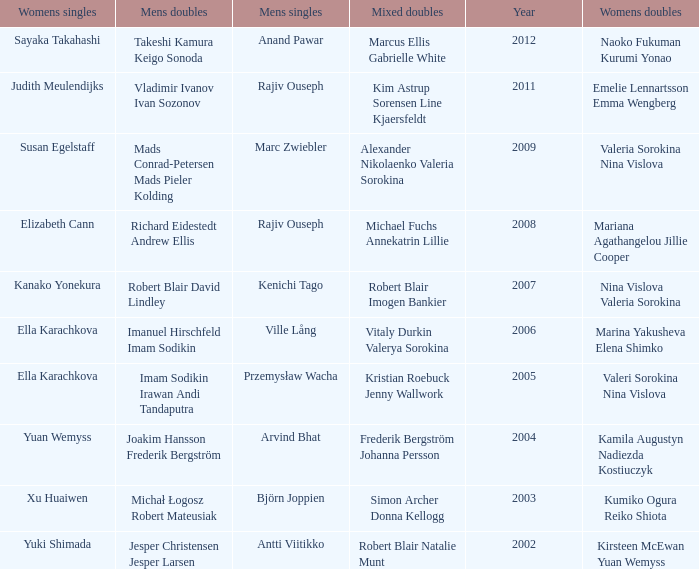What are the womens singles of imam sodikin irawan andi tandaputra? Ella Karachkova. 